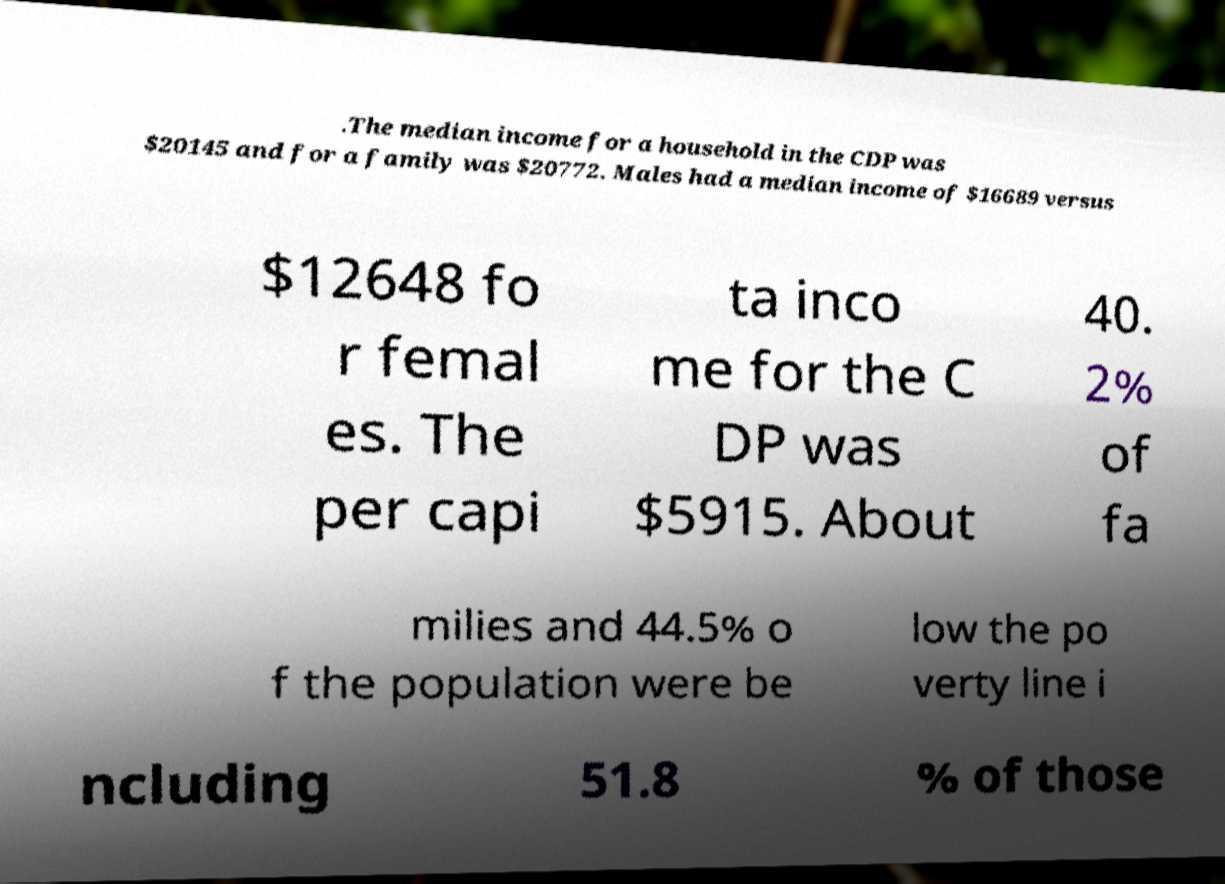What messages or text are displayed in this image? I need them in a readable, typed format. .The median income for a household in the CDP was $20145 and for a family was $20772. Males had a median income of $16689 versus $12648 fo r femal es. The per capi ta inco me for the C DP was $5915. About 40. 2% of fa milies and 44.5% o f the population were be low the po verty line i ncluding 51.8 % of those 